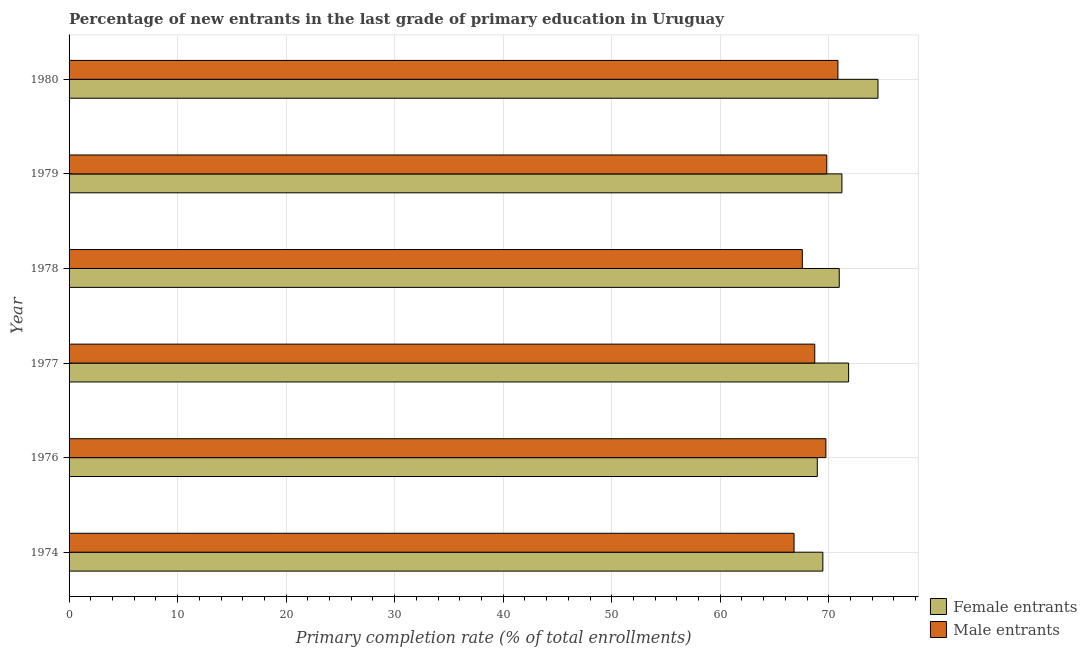How many groups of bars are there?
Provide a short and direct response. 6. How many bars are there on the 5th tick from the bottom?
Keep it short and to the point. 2. What is the label of the 4th group of bars from the top?
Provide a succinct answer. 1977. In how many cases, is the number of bars for a given year not equal to the number of legend labels?
Give a very brief answer. 0. What is the primary completion rate of male entrants in 1974?
Your response must be concise. 66.8. Across all years, what is the maximum primary completion rate of female entrants?
Your response must be concise. 74.53. Across all years, what is the minimum primary completion rate of male entrants?
Ensure brevity in your answer.  66.8. In which year was the primary completion rate of female entrants maximum?
Provide a succinct answer. 1980. In which year was the primary completion rate of male entrants minimum?
Offer a very short reply. 1974. What is the total primary completion rate of female entrants in the graph?
Your answer should be very brief. 426.92. What is the difference between the primary completion rate of female entrants in 1974 and that in 1976?
Offer a very short reply. 0.51. What is the difference between the primary completion rate of male entrants in 1980 and the primary completion rate of female entrants in 1979?
Keep it short and to the point. -0.37. What is the average primary completion rate of female entrants per year?
Offer a very short reply. 71.15. In the year 1978, what is the difference between the primary completion rate of male entrants and primary completion rate of female entrants?
Your response must be concise. -3.4. In how many years, is the primary completion rate of female entrants greater than 62 %?
Your answer should be very brief. 6. What is the ratio of the primary completion rate of female entrants in 1979 to that in 1980?
Keep it short and to the point. 0.95. Is the primary completion rate of male entrants in 1974 less than that in 1976?
Ensure brevity in your answer.  Yes. Is the difference between the primary completion rate of male entrants in 1974 and 1979 greater than the difference between the primary completion rate of female entrants in 1974 and 1979?
Provide a succinct answer. No. What is the difference between the highest and the second highest primary completion rate of female entrants?
Your answer should be very brief. 2.71. What is the difference between the highest and the lowest primary completion rate of female entrants?
Ensure brevity in your answer.  5.59. In how many years, is the primary completion rate of female entrants greater than the average primary completion rate of female entrants taken over all years?
Your answer should be very brief. 3. Is the sum of the primary completion rate of male entrants in 1974 and 1980 greater than the maximum primary completion rate of female entrants across all years?
Ensure brevity in your answer.  Yes. What does the 2nd bar from the top in 1974 represents?
Provide a short and direct response. Female entrants. What does the 1st bar from the bottom in 1976 represents?
Ensure brevity in your answer.  Female entrants. How many bars are there?
Your answer should be compact. 12. What is the difference between two consecutive major ticks on the X-axis?
Ensure brevity in your answer.  10. Does the graph contain any zero values?
Offer a terse response. No. Where does the legend appear in the graph?
Your response must be concise. Bottom right. What is the title of the graph?
Your answer should be very brief. Percentage of new entrants in the last grade of primary education in Uruguay. Does "Girls" appear as one of the legend labels in the graph?
Provide a succinct answer. No. What is the label or title of the X-axis?
Your answer should be very brief. Primary completion rate (% of total enrollments). What is the Primary completion rate (% of total enrollments) of Female entrants in 1974?
Offer a very short reply. 69.45. What is the Primary completion rate (% of total enrollments) in Male entrants in 1974?
Give a very brief answer. 66.8. What is the Primary completion rate (% of total enrollments) of Female entrants in 1976?
Your response must be concise. 68.94. What is the Primary completion rate (% of total enrollments) in Male entrants in 1976?
Provide a succinct answer. 69.73. What is the Primary completion rate (% of total enrollments) of Female entrants in 1977?
Ensure brevity in your answer.  71.82. What is the Primary completion rate (% of total enrollments) in Male entrants in 1977?
Offer a very short reply. 68.71. What is the Primary completion rate (% of total enrollments) of Female entrants in 1978?
Offer a terse response. 70.96. What is the Primary completion rate (% of total enrollments) in Male entrants in 1978?
Your answer should be compact. 67.56. What is the Primary completion rate (% of total enrollments) in Female entrants in 1979?
Offer a very short reply. 71.21. What is the Primary completion rate (% of total enrollments) in Male entrants in 1979?
Your response must be concise. 69.81. What is the Primary completion rate (% of total enrollments) of Female entrants in 1980?
Keep it short and to the point. 74.53. What is the Primary completion rate (% of total enrollments) in Male entrants in 1980?
Make the answer very short. 70.84. Across all years, what is the maximum Primary completion rate (% of total enrollments) in Female entrants?
Keep it short and to the point. 74.53. Across all years, what is the maximum Primary completion rate (% of total enrollments) of Male entrants?
Give a very brief answer. 70.84. Across all years, what is the minimum Primary completion rate (% of total enrollments) in Female entrants?
Give a very brief answer. 68.94. Across all years, what is the minimum Primary completion rate (% of total enrollments) of Male entrants?
Keep it short and to the point. 66.8. What is the total Primary completion rate (% of total enrollments) in Female entrants in the graph?
Make the answer very short. 426.92. What is the total Primary completion rate (% of total enrollments) in Male entrants in the graph?
Make the answer very short. 413.45. What is the difference between the Primary completion rate (% of total enrollments) of Female entrants in 1974 and that in 1976?
Your response must be concise. 0.51. What is the difference between the Primary completion rate (% of total enrollments) of Male entrants in 1974 and that in 1976?
Keep it short and to the point. -2.94. What is the difference between the Primary completion rate (% of total enrollments) in Female entrants in 1974 and that in 1977?
Offer a terse response. -2.37. What is the difference between the Primary completion rate (% of total enrollments) of Male entrants in 1974 and that in 1977?
Your answer should be compact. -1.91. What is the difference between the Primary completion rate (% of total enrollments) of Female entrants in 1974 and that in 1978?
Your answer should be very brief. -1.51. What is the difference between the Primary completion rate (% of total enrollments) of Male entrants in 1974 and that in 1978?
Ensure brevity in your answer.  -0.76. What is the difference between the Primary completion rate (% of total enrollments) of Female entrants in 1974 and that in 1979?
Provide a short and direct response. -1.76. What is the difference between the Primary completion rate (% of total enrollments) in Male entrants in 1974 and that in 1979?
Offer a terse response. -3.01. What is the difference between the Primary completion rate (% of total enrollments) of Female entrants in 1974 and that in 1980?
Offer a terse response. -5.08. What is the difference between the Primary completion rate (% of total enrollments) of Male entrants in 1974 and that in 1980?
Make the answer very short. -4.04. What is the difference between the Primary completion rate (% of total enrollments) in Female entrants in 1976 and that in 1977?
Keep it short and to the point. -2.89. What is the difference between the Primary completion rate (% of total enrollments) of Male entrants in 1976 and that in 1977?
Provide a short and direct response. 1.03. What is the difference between the Primary completion rate (% of total enrollments) of Female entrants in 1976 and that in 1978?
Make the answer very short. -2.02. What is the difference between the Primary completion rate (% of total enrollments) in Male entrants in 1976 and that in 1978?
Make the answer very short. 2.17. What is the difference between the Primary completion rate (% of total enrollments) of Female entrants in 1976 and that in 1979?
Offer a very short reply. -2.27. What is the difference between the Primary completion rate (% of total enrollments) of Male entrants in 1976 and that in 1979?
Your answer should be very brief. -0.08. What is the difference between the Primary completion rate (% of total enrollments) of Female entrants in 1976 and that in 1980?
Make the answer very short. -5.59. What is the difference between the Primary completion rate (% of total enrollments) of Male entrants in 1976 and that in 1980?
Your response must be concise. -1.11. What is the difference between the Primary completion rate (% of total enrollments) of Female entrants in 1977 and that in 1978?
Your response must be concise. 0.86. What is the difference between the Primary completion rate (% of total enrollments) of Male entrants in 1977 and that in 1978?
Provide a short and direct response. 1.15. What is the difference between the Primary completion rate (% of total enrollments) of Female entrants in 1977 and that in 1979?
Keep it short and to the point. 0.61. What is the difference between the Primary completion rate (% of total enrollments) of Male entrants in 1977 and that in 1979?
Keep it short and to the point. -1.11. What is the difference between the Primary completion rate (% of total enrollments) of Female entrants in 1977 and that in 1980?
Ensure brevity in your answer.  -2.71. What is the difference between the Primary completion rate (% of total enrollments) of Male entrants in 1977 and that in 1980?
Give a very brief answer. -2.13. What is the difference between the Primary completion rate (% of total enrollments) of Female entrants in 1978 and that in 1979?
Give a very brief answer. -0.25. What is the difference between the Primary completion rate (% of total enrollments) in Male entrants in 1978 and that in 1979?
Provide a succinct answer. -2.25. What is the difference between the Primary completion rate (% of total enrollments) in Female entrants in 1978 and that in 1980?
Your answer should be very brief. -3.57. What is the difference between the Primary completion rate (% of total enrollments) in Male entrants in 1978 and that in 1980?
Your response must be concise. -3.28. What is the difference between the Primary completion rate (% of total enrollments) of Female entrants in 1979 and that in 1980?
Your answer should be compact. -3.32. What is the difference between the Primary completion rate (% of total enrollments) of Male entrants in 1979 and that in 1980?
Your answer should be compact. -1.03. What is the difference between the Primary completion rate (% of total enrollments) in Female entrants in 1974 and the Primary completion rate (% of total enrollments) in Male entrants in 1976?
Keep it short and to the point. -0.28. What is the difference between the Primary completion rate (% of total enrollments) in Female entrants in 1974 and the Primary completion rate (% of total enrollments) in Male entrants in 1977?
Give a very brief answer. 0.75. What is the difference between the Primary completion rate (% of total enrollments) of Female entrants in 1974 and the Primary completion rate (% of total enrollments) of Male entrants in 1978?
Provide a short and direct response. 1.89. What is the difference between the Primary completion rate (% of total enrollments) in Female entrants in 1974 and the Primary completion rate (% of total enrollments) in Male entrants in 1979?
Provide a succinct answer. -0.36. What is the difference between the Primary completion rate (% of total enrollments) in Female entrants in 1974 and the Primary completion rate (% of total enrollments) in Male entrants in 1980?
Ensure brevity in your answer.  -1.39. What is the difference between the Primary completion rate (% of total enrollments) of Female entrants in 1976 and the Primary completion rate (% of total enrollments) of Male entrants in 1977?
Ensure brevity in your answer.  0.23. What is the difference between the Primary completion rate (% of total enrollments) in Female entrants in 1976 and the Primary completion rate (% of total enrollments) in Male entrants in 1978?
Give a very brief answer. 1.38. What is the difference between the Primary completion rate (% of total enrollments) of Female entrants in 1976 and the Primary completion rate (% of total enrollments) of Male entrants in 1979?
Your answer should be very brief. -0.87. What is the difference between the Primary completion rate (% of total enrollments) in Female entrants in 1976 and the Primary completion rate (% of total enrollments) in Male entrants in 1980?
Offer a terse response. -1.9. What is the difference between the Primary completion rate (% of total enrollments) in Female entrants in 1977 and the Primary completion rate (% of total enrollments) in Male entrants in 1978?
Provide a succinct answer. 4.26. What is the difference between the Primary completion rate (% of total enrollments) in Female entrants in 1977 and the Primary completion rate (% of total enrollments) in Male entrants in 1979?
Keep it short and to the point. 2.01. What is the difference between the Primary completion rate (% of total enrollments) of Female entrants in 1977 and the Primary completion rate (% of total enrollments) of Male entrants in 1980?
Ensure brevity in your answer.  0.98. What is the difference between the Primary completion rate (% of total enrollments) in Female entrants in 1978 and the Primary completion rate (% of total enrollments) in Male entrants in 1979?
Provide a short and direct response. 1.15. What is the difference between the Primary completion rate (% of total enrollments) of Female entrants in 1978 and the Primary completion rate (% of total enrollments) of Male entrants in 1980?
Your answer should be very brief. 0.12. What is the difference between the Primary completion rate (% of total enrollments) of Female entrants in 1979 and the Primary completion rate (% of total enrollments) of Male entrants in 1980?
Provide a succinct answer. 0.37. What is the average Primary completion rate (% of total enrollments) of Female entrants per year?
Your response must be concise. 71.15. What is the average Primary completion rate (% of total enrollments) in Male entrants per year?
Give a very brief answer. 68.91. In the year 1974, what is the difference between the Primary completion rate (% of total enrollments) of Female entrants and Primary completion rate (% of total enrollments) of Male entrants?
Provide a succinct answer. 2.66. In the year 1976, what is the difference between the Primary completion rate (% of total enrollments) of Female entrants and Primary completion rate (% of total enrollments) of Male entrants?
Offer a terse response. -0.79. In the year 1977, what is the difference between the Primary completion rate (% of total enrollments) in Female entrants and Primary completion rate (% of total enrollments) in Male entrants?
Your answer should be very brief. 3.12. In the year 1978, what is the difference between the Primary completion rate (% of total enrollments) of Female entrants and Primary completion rate (% of total enrollments) of Male entrants?
Offer a terse response. 3.4. In the year 1979, what is the difference between the Primary completion rate (% of total enrollments) of Female entrants and Primary completion rate (% of total enrollments) of Male entrants?
Ensure brevity in your answer.  1.4. In the year 1980, what is the difference between the Primary completion rate (% of total enrollments) in Female entrants and Primary completion rate (% of total enrollments) in Male entrants?
Offer a very short reply. 3.69. What is the ratio of the Primary completion rate (% of total enrollments) of Female entrants in 1974 to that in 1976?
Your answer should be very brief. 1.01. What is the ratio of the Primary completion rate (% of total enrollments) of Male entrants in 1974 to that in 1976?
Ensure brevity in your answer.  0.96. What is the ratio of the Primary completion rate (% of total enrollments) in Female entrants in 1974 to that in 1977?
Give a very brief answer. 0.97. What is the ratio of the Primary completion rate (% of total enrollments) in Male entrants in 1974 to that in 1977?
Your response must be concise. 0.97. What is the ratio of the Primary completion rate (% of total enrollments) in Female entrants in 1974 to that in 1978?
Your answer should be very brief. 0.98. What is the ratio of the Primary completion rate (% of total enrollments) in Male entrants in 1974 to that in 1978?
Keep it short and to the point. 0.99. What is the ratio of the Primary completion rate (% of total enrollments) in Female entrants in 1974 to that in 1979?
Offer a very short reply. 0.98. What is the ratio of the Primary completion rate (% of total enrollments) of Male entrants in 1974 to that in 1979?
Provide a short and direct response. 0.96. What is the ratio of the Primary completion rate (% of total enrollments) of Female entrants in 1974 to that in 1980?
Offer a very short reply. 0.93. What is the ratio of the Primary completion rate (% of total enrollments) in Male entrants in 1974 to that in 1980?
Keep it short and to the point. 0.94. What is the ratio of the Primary completion rate (% of total enrollments) in Female entrants in 1976 to that in 1977?
Offer a very short reply. 0.96. What is the ratio of the Primary completion rate (% of total enrollments) in Male entrants in 1976 to that in 1977?
Make the answer very short. 1.01. What is the ratio of the Primary completion rate (% of total enrollments) of Female entrants in 1976 to that in 1978?
Your answer should be compact. 0.97. What is the ratio of the Primary completion rate (% of total enrollments) of Male entrants in 1976 to that in 1978?
Keep it short and to the point. 1.03. What is the ratio of the Primary completion rate (% of total enrollments) in Female entrants in 1976 to that in 1979?
Make the answer very short. 0.97. What is the ratio of the Primary completion rate (% of total enrollments) of Female entrants in 1976 to that in 1980?
Your answer should be very brief. 0.93. What is the ratio of the Primary completion rate (% of total enrollments) of Male entrants in 1976 to that in 1980?
Ensure brevity in your answer.  0.98. What is the ratio of the Primary completion rate (% of total enrollments) in Female entrants in 1977 to that in 1978?
Offer a terse response. 1.01. What is the ratio of the Primary completion rate (% of total enrollments) in Male entrants in 1977 to that in 1978?
Provide a succinct answer. 1.02. What is the ratio of the Primary completion rate (% of total enrollments) of Female entrants in 1977 to that in 1979?
Offer a very short reply. 1.01. What is the ratio of the Primary completion rate (% of total enrollments) in Male entrants in 1977 to that in 1979?
Keep it short and to the point. 0.98. What is the ratio of the Primary completion rate (% of total enrollments) of Female entrants in 1977 to that in 1980?
Provide a succinct answer. 0.96. What is the ratio of the Primary completion rate (% of total enrollments) of Male entrants in 1977 to that in 1980?
Your answer should be compact. 0.97. What is the ratio of the Primary completion rate (% of total enrollments) of Female entrants in 1978 to that in 1979?
Provide a succinct answer. 1. What is the ratio of the Primary completion rate (% of total enrollments) in Female entrants in 1978 to that in 1980?
Your answer should be compact. 0.95. What is the ratio of the Primary completion rate (% of total enrollments) of Male entrants in 1978 to that in 1980?
Offer a very short reply. 0.95. What is the ratio of the Primary completion rate (% of total enrollments) of Female entrants in 1979 to that in 1980?
Your answer should be compact. 0.96. What is the ratio of the Primary completion rate (% of total enrollments) of Male entrants in 1979 to that in 1980?
Provide a short and direct response. 0.99. What is the difference between the highest and the second highest Primary completion rate (% of total enrollments) of Female entrants?
Offer a terse response. 2.71. What is the difference between the highest and the second highest Primary completion rate (% of total enrollments) of Male entrants?
Give a very brief answer. 1.03. What is the difference between the highest and the lowest Primary completion rate (% of total enrollments) in Female entrants?
Keep it short and to the point. 5.59. What is the difference between the highest and the lowest Primary completion rate (% of total enrollments) of Male entrants?
Ensure brevity in your answer.  4.04. 